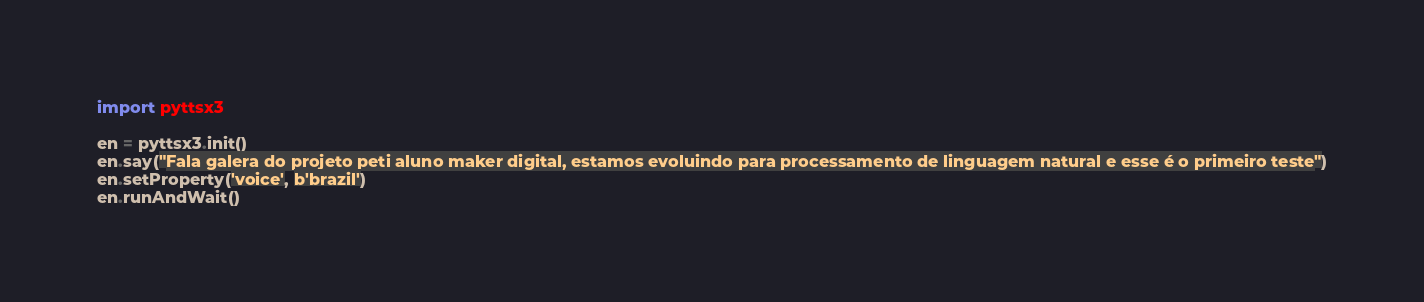<code> <loc_0><loc_0><loc_500><loc_500><_Python_>import pyttsx3

en = pyttsx3.init()
en.say("Fala galera do projeto peti aluno maker digital, estamos evoluindo para processamento de linguagem natural e esse é o primeiro teste")
en.setProperty('voice', b'brazil')
en.runAndWait()
</code> 